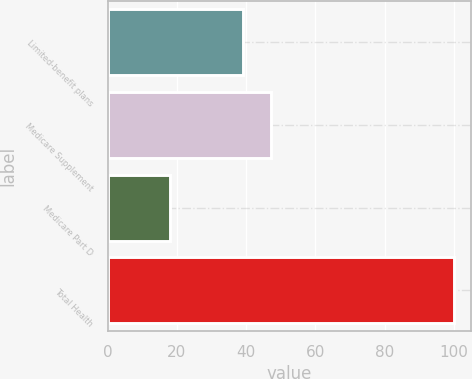Convert chart to OTSL. <chart><loc_0><loc_0><loc_500><loc_500><bar_chart><fcel>Limited-benefit plans<fcel>Medicare Supplement<fcel>Medicare Part D<fcel>Total Health<nl><fcel>39<fcel>47.2<fcel>18<fcel>100<nl></chart> 